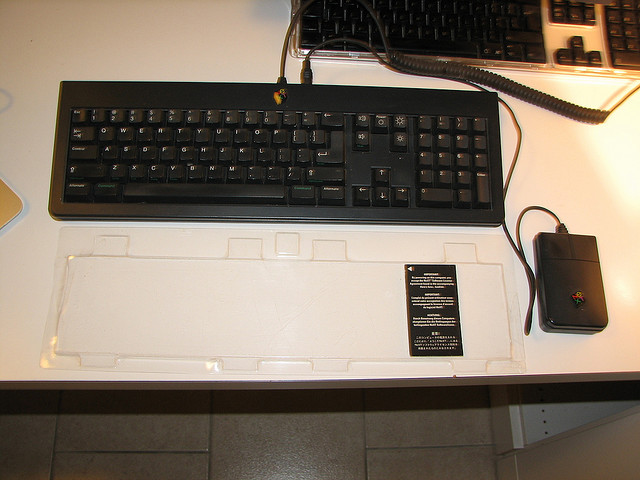<image>What company is named? I am not sure. The company name can be Dell, IBM, or not mentioned at all. What company is named? I don't know what company is named. It can be seen 'dell' or 'ibm'. 